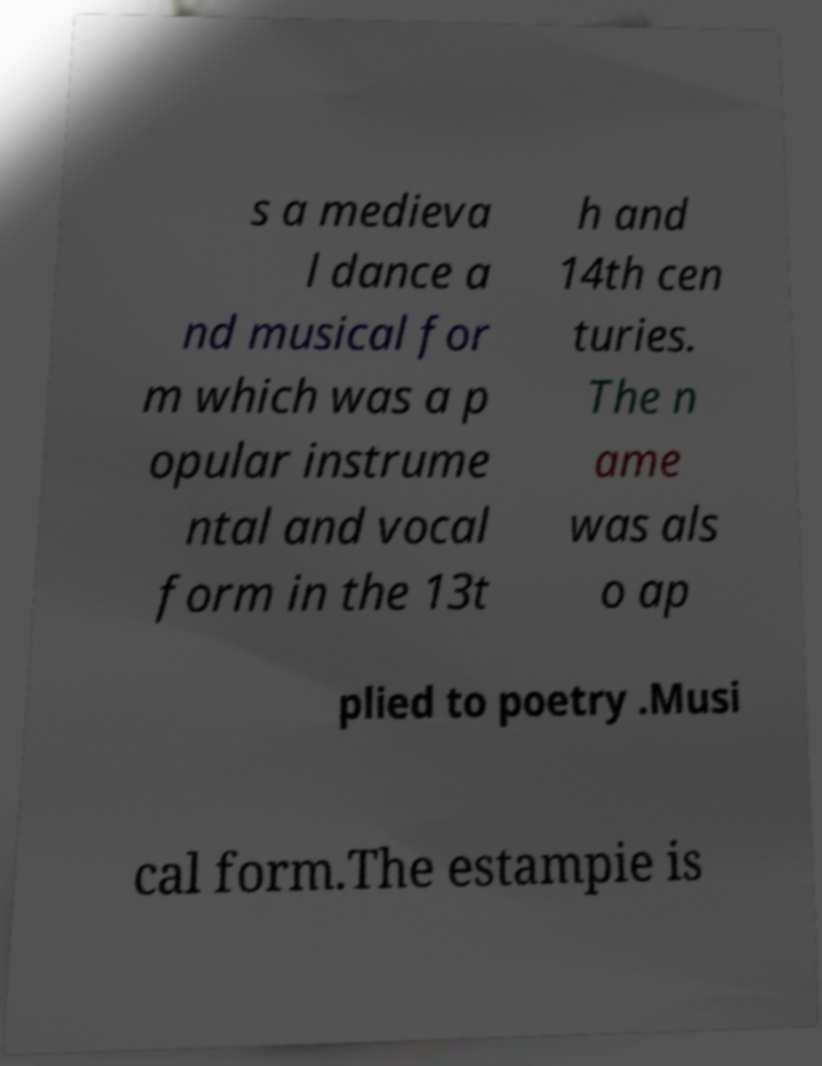For documentation purposes, I need the text within this image transcribed. Could you provide that? s a medieva l dance a nd musical for m which was a p opular instrume ntal and vocal form in the 13t h and 14th cen turies. The n ame was als o ap plied to poetry .Musi cal form.The estampie is 